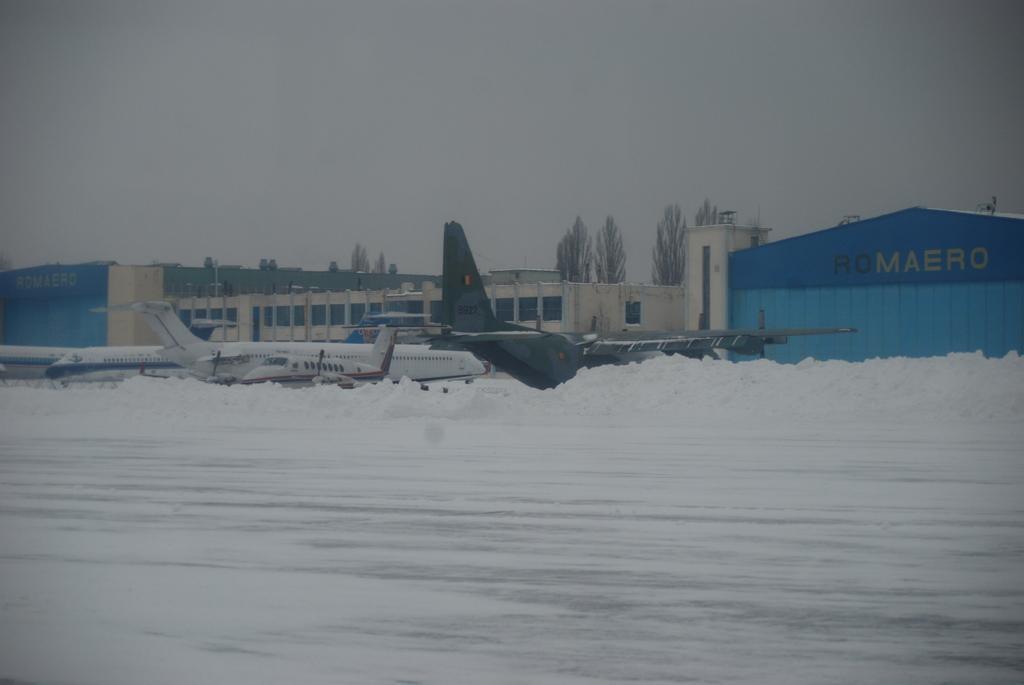Describe this image in one or two sentences. In this picture we can see some planes are parked in the ground. Behind there is a blue color shade tent and white color building. In the background there are some trees. 